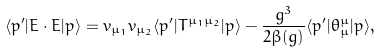<formula> <loc_0><loc_0><loc_500><loc_500>\langle p ^ { \prime } | E \cdot E | p \rangle = v _ { \mu _ { 1 } } v _ { \mu _ { 2 } } \langle p ^ { \prime } | T ^ { \mu _ { 1 } \mu _ { 2 } } | p \rangle - \frac { g ^ { 3 } } { 2 \beta ( g ) } \langle p ^ { \prime } | \theta _ { \mu } ^ { \mu } | p \rangle ,</formula> 